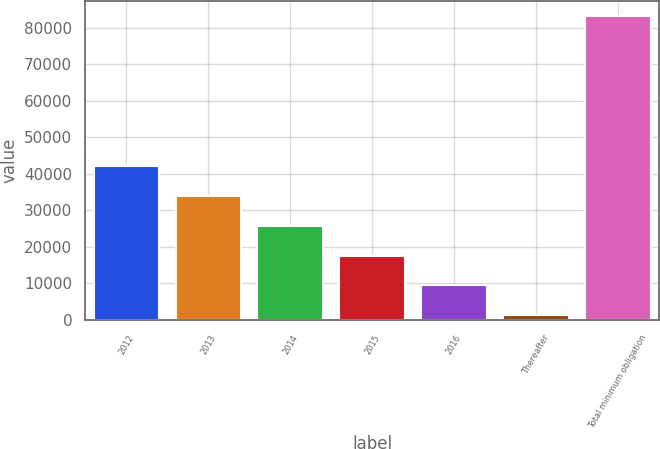<chart> <loc_0><loc_0><loc_500><loc_500><bar_chart><fcel>2012<fcel>2013<fcel>2014<fcel>2015<fcel>2016<fcel>Thereafter<fcel>Total minimum obligation<nl><fcel>42195<fcel>33997<fcel>25799<fcel>17601<fcel>9403<fcel>1205<fcel>83185<nl></chart> 